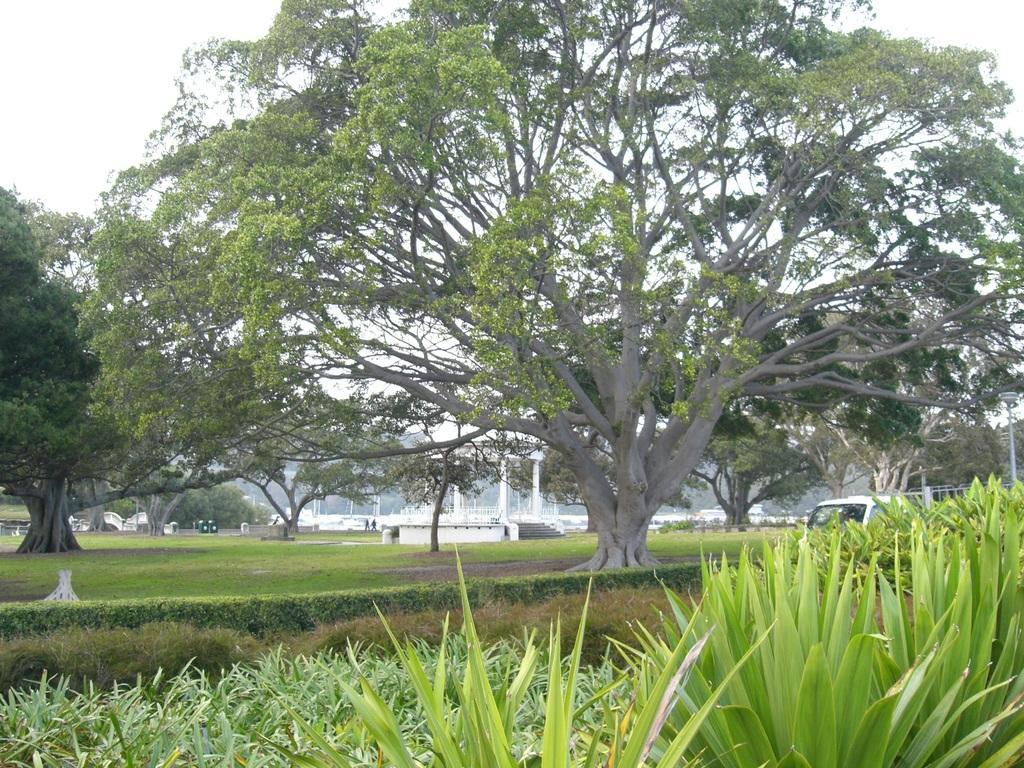Describe this image in one or two sentences. This picture is clicked outside. In the foreground we can see the plants and the green grass. In the center there are some trees and some buildings and there are some objects. In the background there is a sky. 